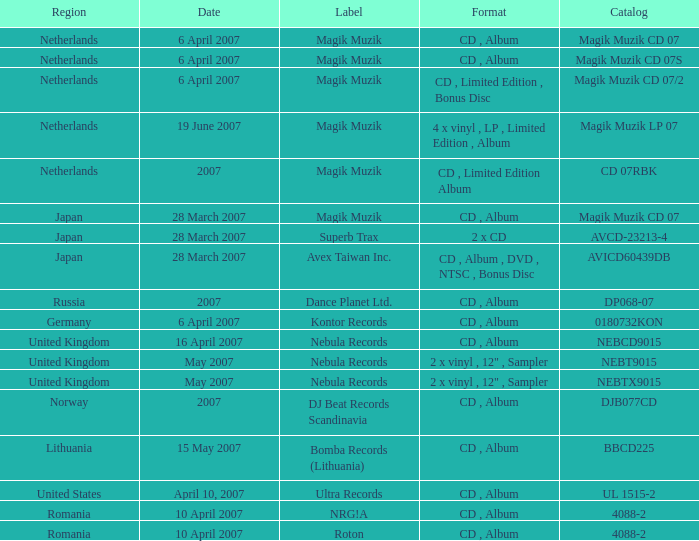Which record label launched the catalog magik muzik cd 07 on 28 march 2007? Magik Muzik. 